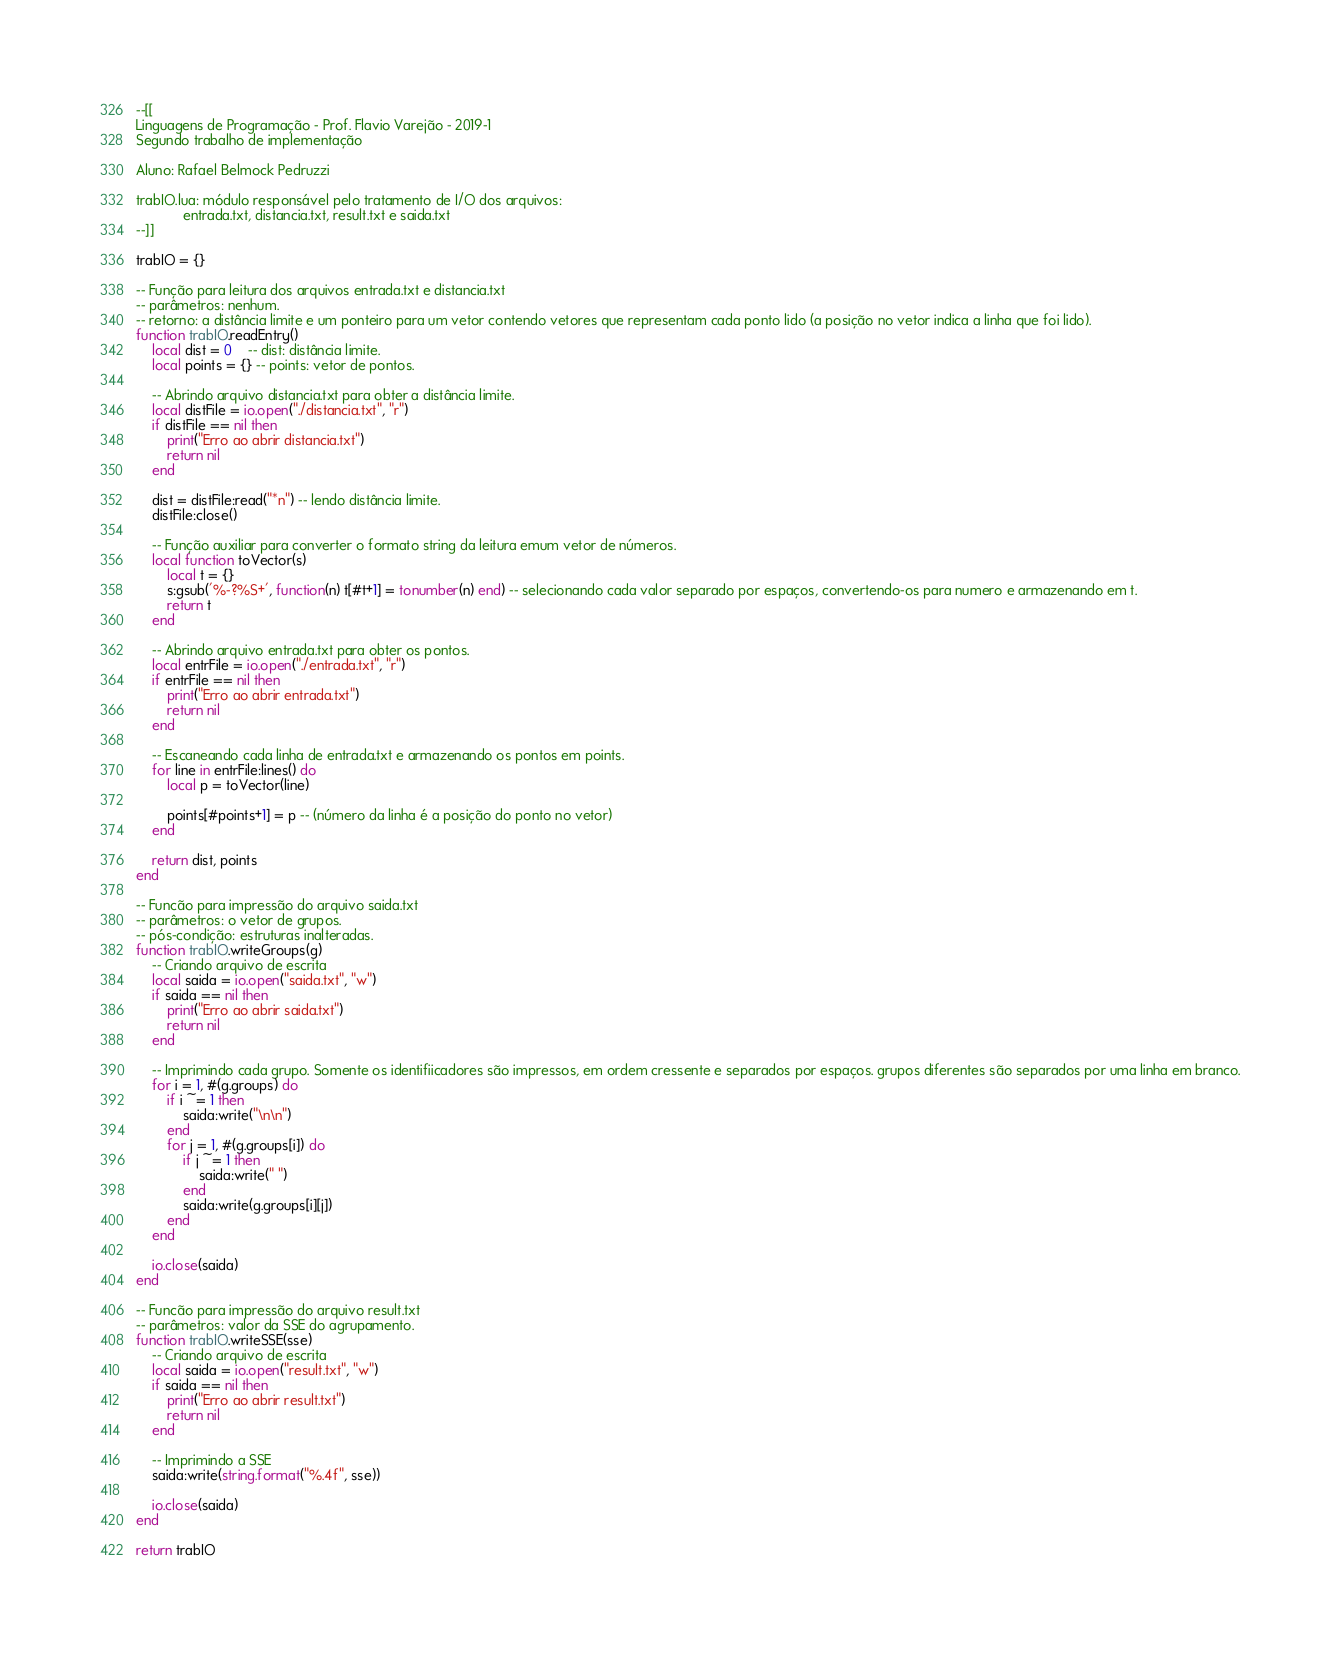Convert code to text. <code><loc_0><loc_0><loc_500><loc_500><_Lua_>--[[
Linguagens de Programação - Prof. Flavio Varejão - 2019-1
Segundo trabalho de implementação

Aluno: Rafael Belmock Pedruzzi

trabIO.lua:	módulo responsável pelo tratamento de I/O dos arquivos:
			entrada.txt, distancia.txt, result.txt e saida.txt
--]]

trabIO = {}

-- Função para leitura dos arquivos entrada.txt e distancia.txt
-- parâmetros: nenhum.
-- retorno: a distância limite e um ponteiro para um vetor contendo vetores que representam cada ponto lido (a posição no vetor indica a linha que foi lido).
function trabIO.readEntry()
	local dist = 0    -- dist: distância limite.
	local points = {} -- points: vetor de pontos.

	-- Abrindo arquivo distancia.txt para obter a distância limite.
	local distFile = io.open("./distancia.txt", "r")
	if distFile == nil then
        print("Erro ao abrir distancia.txt")
		return nil
    end

    dist = distFile:read("*n") -- lendo distância limite.
    distFile:close()

	-- Função auxiliar para converter o formato string da leitura emum vetor de números.
    local function toVector(s)
        local t = {}
        s:gsub('%-?%S+', function(n) t[#t+1] = tonumber(n) end) -- selecionando cada valor separado por espaços, convertendo-os para numero e armazenando em t.
        return t
    end

    -- Abrindo arquivo entrada.txt para obter os pontos.
	local entrFile = io.open("./entrada.txt", "r")
	if entrFile == nil then
        print("Erro ao abrir entrada.txt")
		return nil
    end

	-- Escaneando cada linha de entrada.txt e armazenando os pontos em points.
	for line in entrFile:lines() do
        local p = toVector(line)

		points[#points+1] = p -- (número da linha é a posição do ponto no vetor)
    end

	return dist, points
end

-- Funcão para impressão do arquivo saida.txt
-- parâmetros: o vetor de grupos.
-- pós-condição: estruturas inalteradas.
function trabIO.writeGroups(g)
	-- Criando arquivo de escrita
	local saida = io.open("saida.txt", "w")
	if saida == nil then
		print("Erro ao abrir saida.txt")
		return nil
    end

	-- Imprimindo cada grupo. Somente os identifiicadores são impressos, em ordem cressente e separados por espaços. grupos diferentes são separados por uma linha em branco.
	for i = 1, #(g.groups) do
		if i ~= 1 then
			saida:write("\n\n")
        end
		for j = 1, #(g.groups[i]) do
			if j ~= 1 then
				saida:write(" ")
            end
			saida:write(g.groups[i][j])
		end
    end
    
    io.close(saida)
end

-- Funcão para impressão do arquivo result.txt
-- parâmetros: valor da SSE do agrupamento.
function trabIO.writeSSE(sse)
	-- Criando arquivo de escrita
	local saida = io.open("result.txt", "w")
	if saida == nil then
		print("Erro ao abrir result.txt")
		return nil
    end

	-- Imprimindo a SSE
	saida:write(string.format("%.4f", sse))

    io.close(saida)
end

return trabIO</code> 